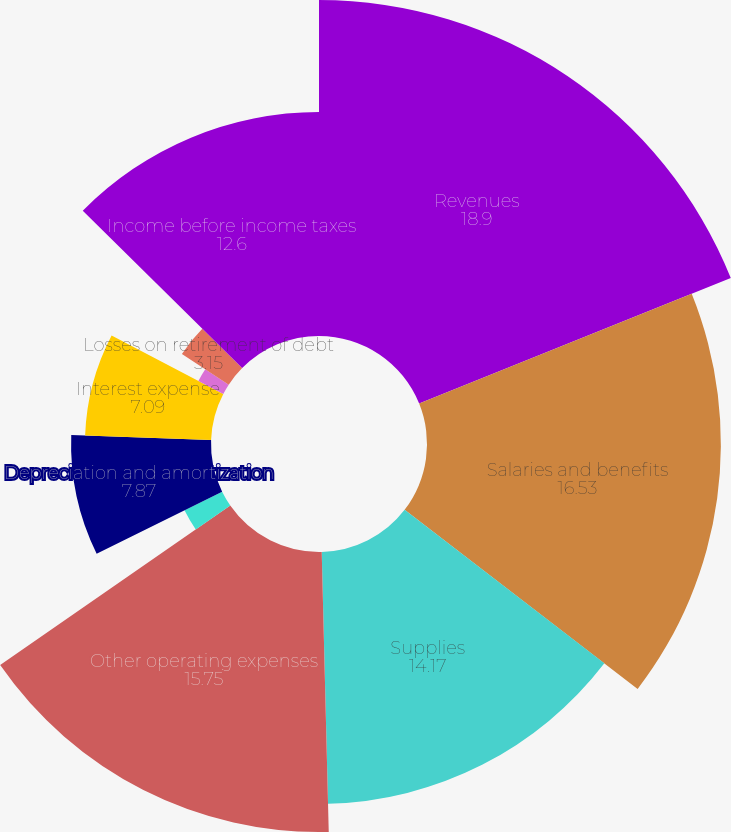Convert chart. <chart><loc_0><loc_0><loc_500><loc_500><pie_chart><fcel>Revenues<fcel>Salaries and benefits<fcel>Supplies<fcel>Other operating expenses<fcel>Equity in earnings of<fcel>Depreciation and amortization<fcel>Interest expense<fcel>Losses (gains) on sales of<fcel>Losses on retirement of debt<fcel>Income before income taxes<nl><fcel>18.9%<fcel>16.53%<fcel>14.17%<fcel>15.75%<fcel>2.36%<fcel>7.87%<fcel>7.09%<fcel>1.58%<fcel>3.15%<fcel>12.6%<nl></chart> 